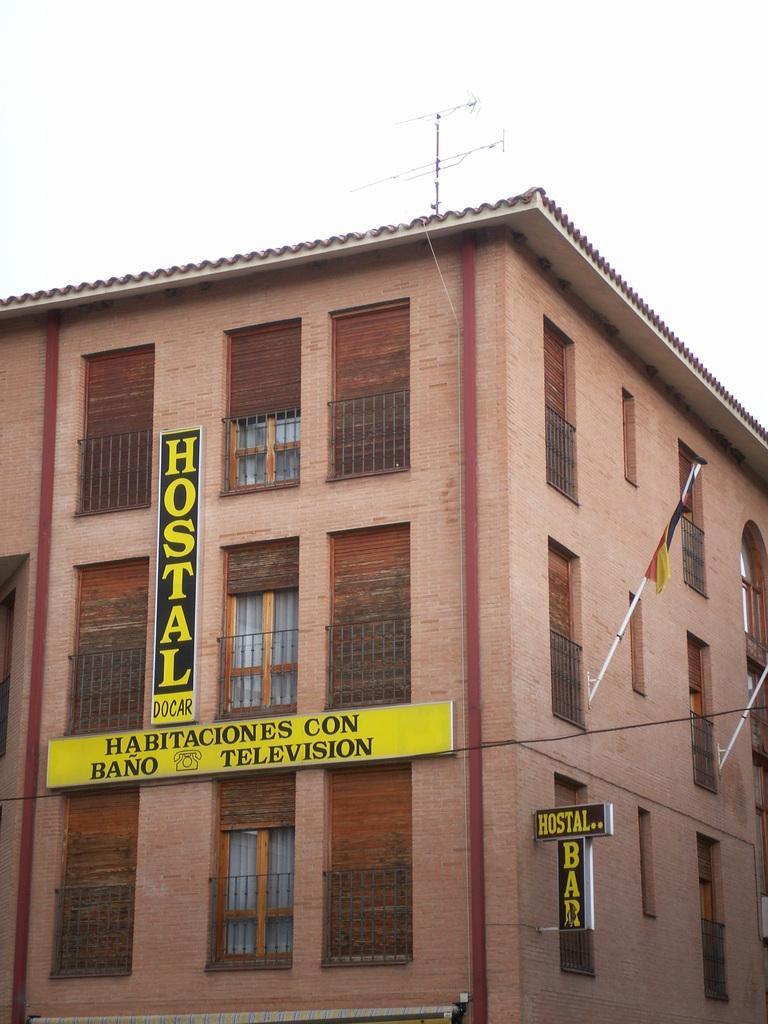In one or two sentences, can you explain what this image depicts? In this picture there is a building which has hostal docar and something written on it and there is a flag attached to the pole in the right corner. 